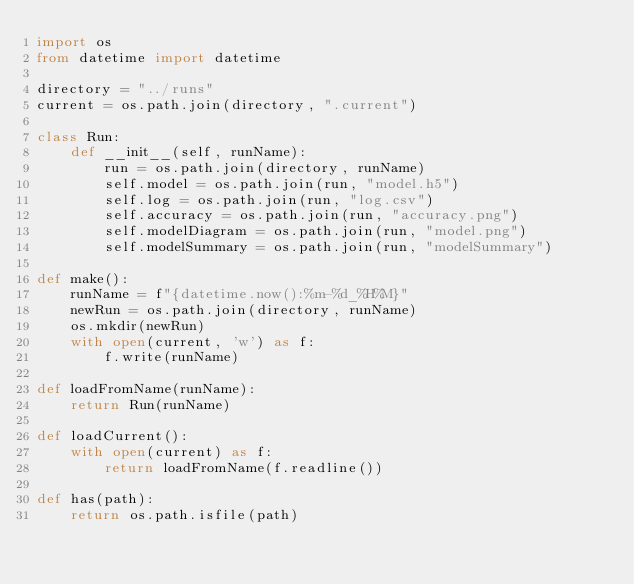Convert code to text. <code><loc_0><loc_0><loc_500><loc_500><_Python_>import os
from datetime import datetime

directory = "../runs"
current = os.path.join(directory, ".current")

class Run:
    def __init__(self, runName):
        run = os.path.join(directory, runName)
        self.model = os.path.join(run, "model.h5")
        self.log = os.path.join(run, "log.csv")
        self.accuracy = os.path.join(run, "accuracy.png")
        self.modelDiagram = os.path.join(run, "model.png")
        self.modelSummary = os.path.join(run, "modelSummary")

def make():
    runName = f"{datetime.now():%m-%d_%H%M}"
    newRun = os.path.join(directory, runName)
    os.mkdir(newRun)
    with open(current, 'w') as f:
        f.write(runName)
    
def loadFromName(runName):
    return Run(runName)

def loadCurrent():
    with open(current) as f:
        return loadFromName(f.readline())

def has(path):
    return os.path.isfile(path)
</code> 